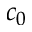Convert formula to latex. <formula><loc_0><loc_0><loc_500><loc_500>c _ { 0 }</formula> 